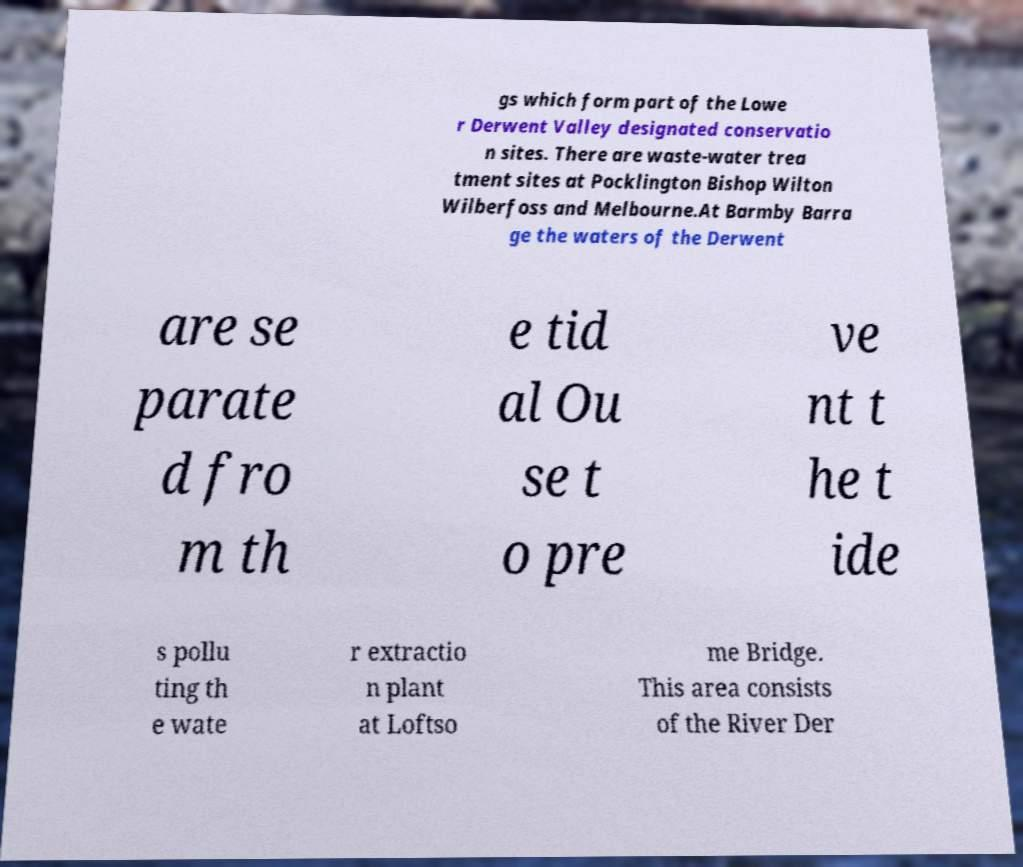Can you accurately transcribe the text from the provided image for me? gs which form part of the Lowe r Derwent Valley designated conservatio n sites. There are waste-water trea tment sites at Pocklington Bishop Wilton Wilberfoss and Melbourne.At Barmby Barra ge the waters of the Derwent are se parate d fro m th e tid al Ou se t o pre ve nt t he t ide s pollu ting th e wate r extractio n plant at Loftso me Bridge. This area consists of the River Der 